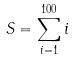<formula> <loc_0><loc_0><loc_500><loc_500>S = \sum _ { i = 1 } ^ { 1 0 0 } i</formula> 